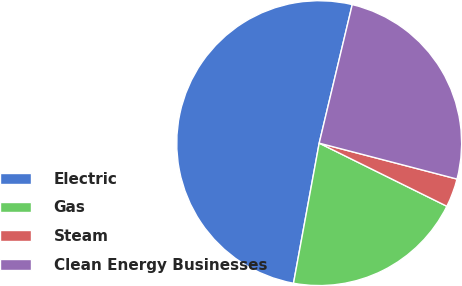Convert chart to OTSL. <chart><loc_0><loc_0><loc_500><loc_500><pie_chart><fcel>Electric<fcel>Gas<fcel>Steam<fcel>Clean Energy Businesses<nl><fcel>50.84%<fcel>20.58%<fcel>3.25%<fcel>25.33%<nl></chart> 